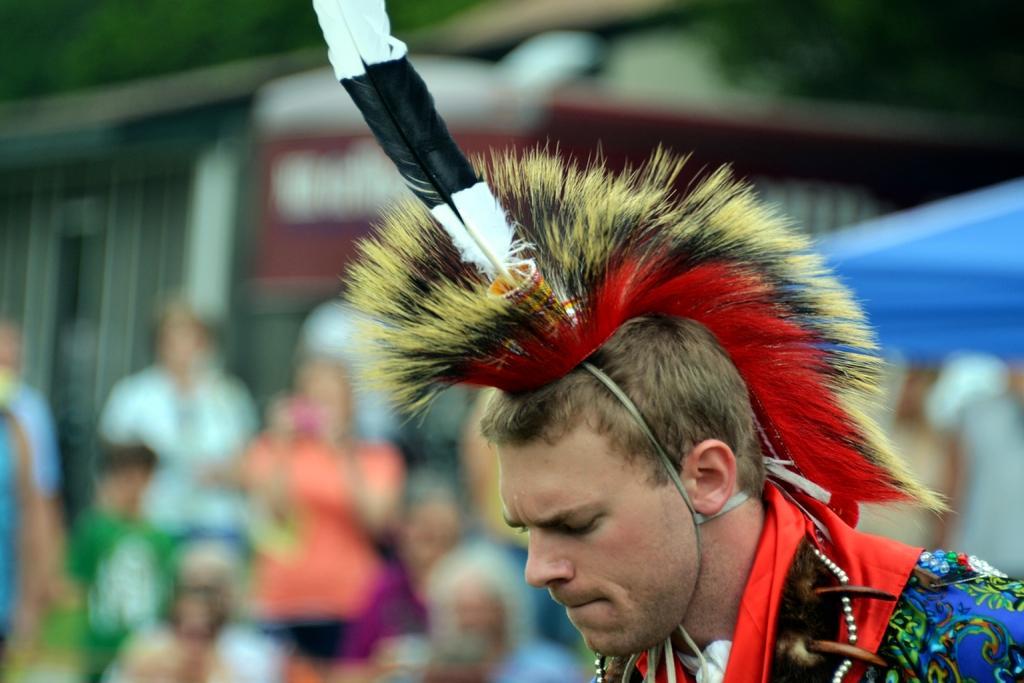How would you summarize this image in a sentence or two? On the right side, there is a person in a dress. And the background is blurred. 